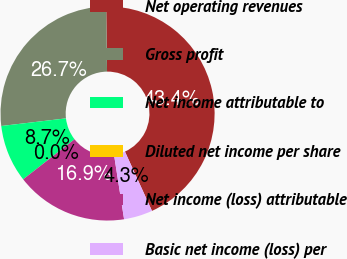<chart> <loc_0><loc_0><loc_500><loc_500><pie_chart><fcel>Net operating revenues<fcel>Gross profit<fcel>Net income attributable to<fcel>Diluted net income per share<fcel>Net income (loss) attributable<fcel>Basic net income (loss) per<nl><fcel>43.39%<fcel>26.66%<fcel>8.68%<fcel>0.0%<fcel>16.92%<fcel>4.34%<nl></chart> 